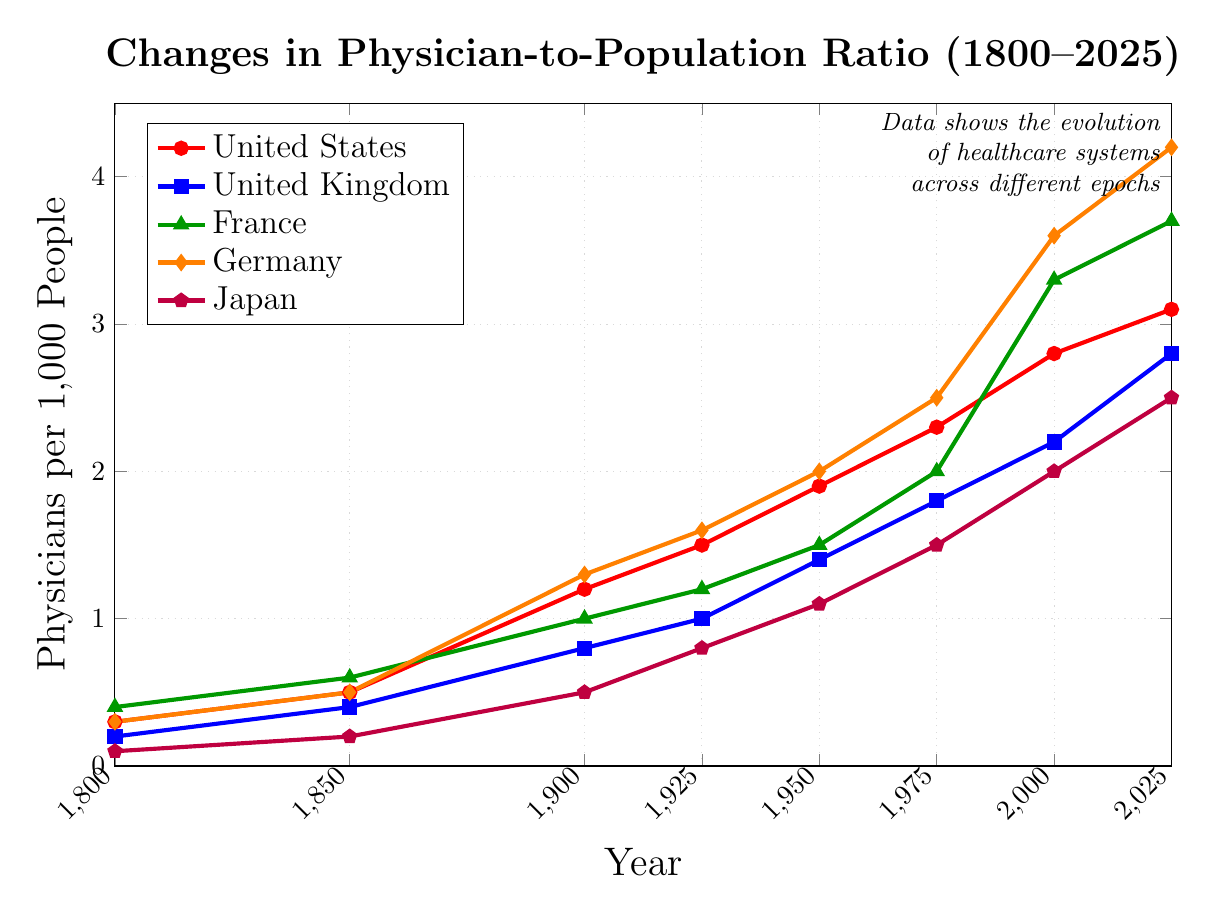What country had the highest physician-to-population ratio in 1925? Look at the 1925 data points for all the countries. Compare the values: United States (1.5), United Kingdom (1.0), France (1.2), Germany (1.6), Japan (0.8). The highest value is Germany (1.6)
Answer: Germany Which two countries had an equal physician-to-population ratio in 1850? Look at the 1850 data points and find pairs of equal values: United States (0.5), United Kingdom (0.4), France (0.6), Germany (0.5), Japan (0.2). The equal values are United States and Germany (both 0.5)
Answer: United States and Germany By how much did France's physician-to-population ratio increase from 1900 to 2000? First, look at the values for France in 1900 (1.0) and 2000 (3.3). Subtract the 1900 value from the 2000 value: 3.3 - 1.0 = 2.3
Answer: 2.3 Which country showed the greatest increase in the physician-to-population ratio between 1925 and 1975? Calculate the increase for each country from 1925 to 1975: United States (2.3 - 1.5 = 0.8), United Kingdom (1.8 - 1.0 = 0.8), France (2.0 - 1.2 = 0.8), Germany (2.5 - 1.6 = 0.9), Japan (1.5 - 0.8 = 0.7). The greatest increase is in Germany (0.9)
Answer: Germany What is the average physician-to-population ratio for Japan across all years? Add all the values for Japan and divide by the number of data points: (0.1 + 0.2 + 0.5 + 0.8 + 1.1 + 1.5 + 2.0 + 2.5) / 8 = 8.7 / 8 = 1.0875
Answer: 1.0875 How many times did Germany’s physician-to-population ratio exceed 2.0? Identify the years when Germany’s value exceeds 2.0: 1950 (2.0), 1975 (2.5), 2000 (3.6), 2025 (4.2). This happens 3 times
Answer: 3 Which country had the slowest growth in physician-to-population ratio between 1900 and 1950? Calculate the increase for each country from 1900 to 1950: United States (1.9 - 1.2 = 0.7), United Kingdom (1.4 - 0.8 = 0.6), France (1.5 - 1.0 = 0.5), Germany (2.0 - 1.3 = 0.7), Japan (1.1 - 0.5 = 0.6). The slowest growth is in France (0.5)
Answer: France What is the ratio difference between the United States and Japan in 2025? Look at the values for 2025: United States (3.1), Japan (2.5). Subtract Japan's value from the United States’ value: 3.1 - 2.5 = 0.6
Answer: 0.6 